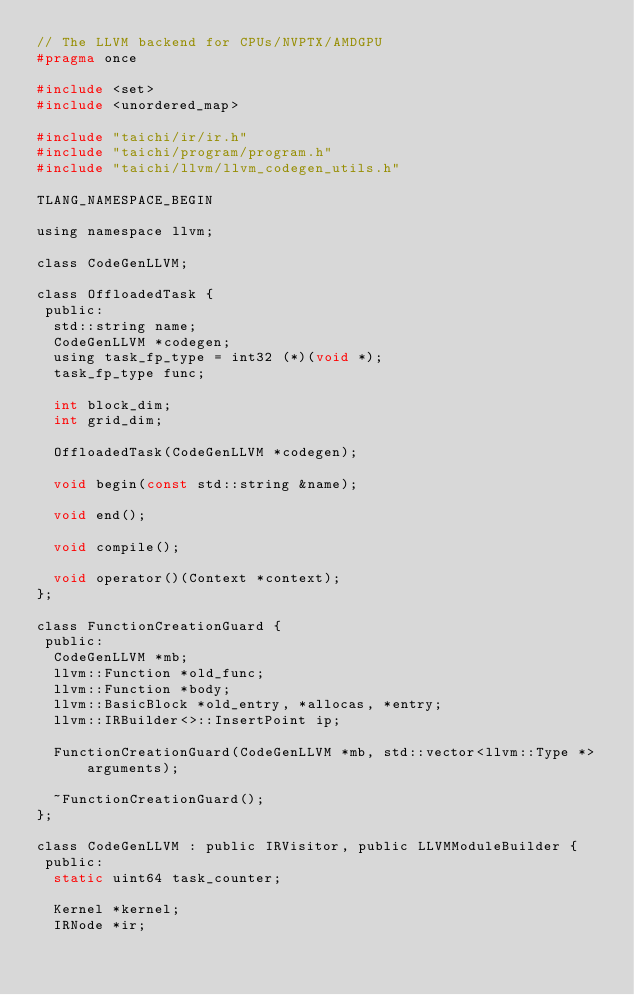<code> <loc_0><loc_0><loc_500><loc_500><_C_>// The LLVM backend for CPUs/NVPTX/AMDGPU
#pragma once

#include <set>
#include <unordered_map>

#include "taichi/ir/ir.h"
#include "taichi/program/program.h"
#include "taichi/llvm/llvm_codegen_utils.h"

TLANG_NAMESPACE_BEGIN

using namespace llvm;

class CodeGenLLVM;

class OffloadedTask {
 public:
  std::string name;
  CodeGenLLVM *codegen;
  using task_fp_type = int32 (*)(void *);
  task_fp_type func;

  int block_dim;
  int grid_dim;

  OffloadedTask(CodeGenLLVM *codegen);

  void begin(const std::string &name);

  void end();

  void compile();

  void operator()(Context *context);
};

class FunctionCreationGuard {
 public:
  CodeGenLLVM *mb;
  llvm::Function *old_func;
  llvm::Function *body;
  llvm::BasicBlock *old_entry, *allocas, *entry;
  llvm::IRBuilder<>::InsertPoint ip;

  FunctionCreationGuard(CodeGenLLVM *mb, std::vector<llvm::Type *> arguments);

  ~FunctionCreationGuard();
};

class CodeGenLLVM : public IRVisitor, public LLVMModuleBuilder {
 public:
  static uint64 task_counter;

  Kernel *kernel;
  IRNode *ir;</code> 